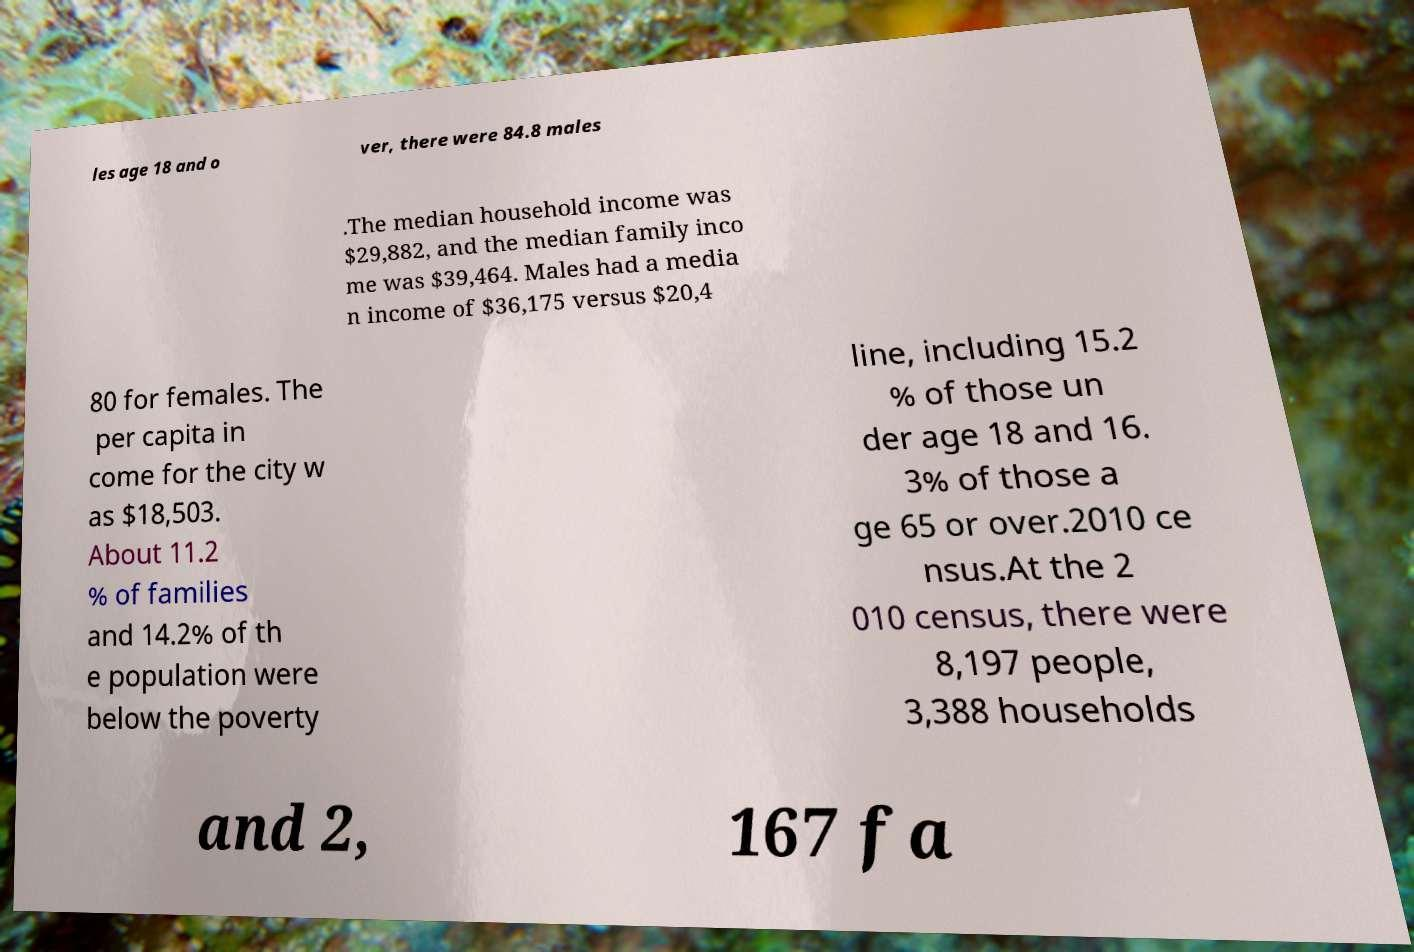For documentation purposes, I need the text within this image transcribed. Could you provide that? les age 18 and o ver, there were 84.8 males .The median household income was $29,882, and the median family inco me was $39,464. Males had a media n income of $36,175 versus $20,4 80 for females. The per capita in come for the city w as $18,503. About 11.2 % of families and 14.2% of th e population were below the poverty line, including 15.2 % of those un der age 18 and 16. 3% of those a ge 65 or over.2010 ce nsus.At the 2 010 census, there were 8,197 people, 3,388 households and 2, 167 fa 